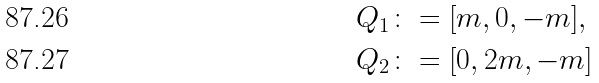<formula> <loc_0><loc_0><loc_500><loc_500>Q _ { 1 } & \colon = [ m , 0 , - m ] , \\ Q _ { 2 } & \colon = [ 0 , 2 m , - m ]</formula> 